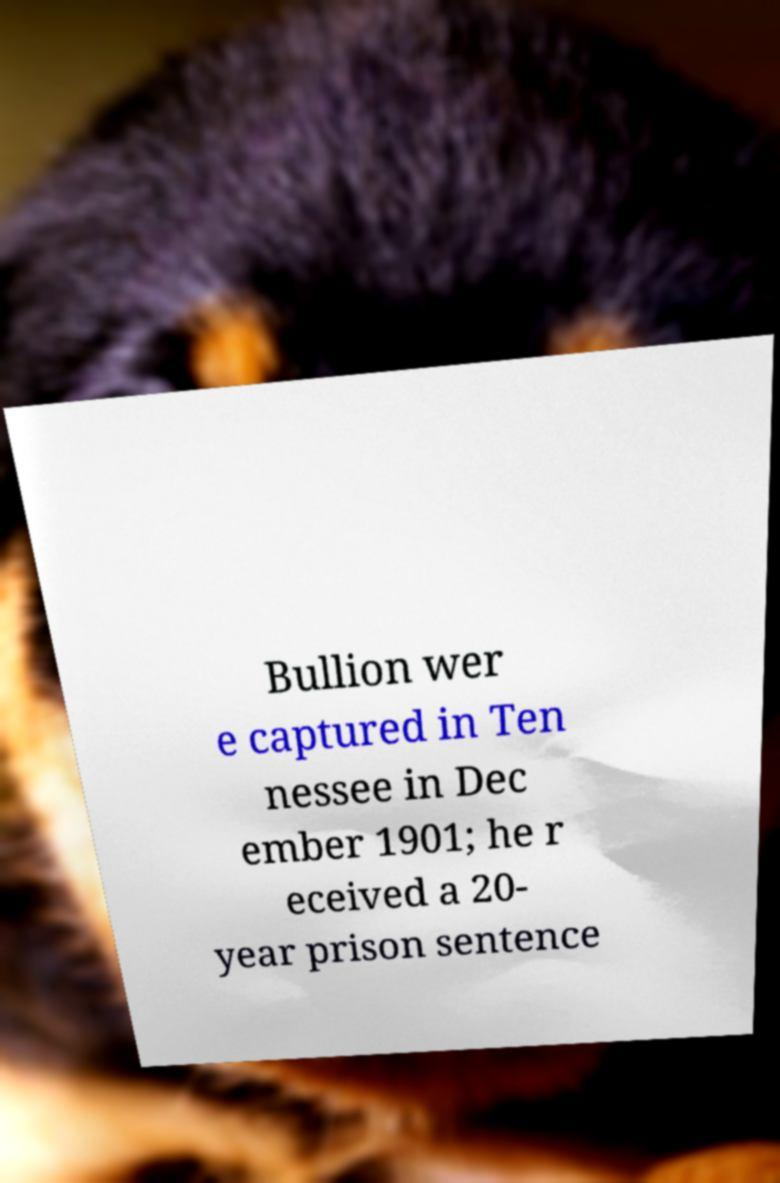Can you accurately transcribe the text from the provided image for me? Bullion wer e captured in Ten nessee in Dec ember 1901; he r eceived a 20- year prison sentence 